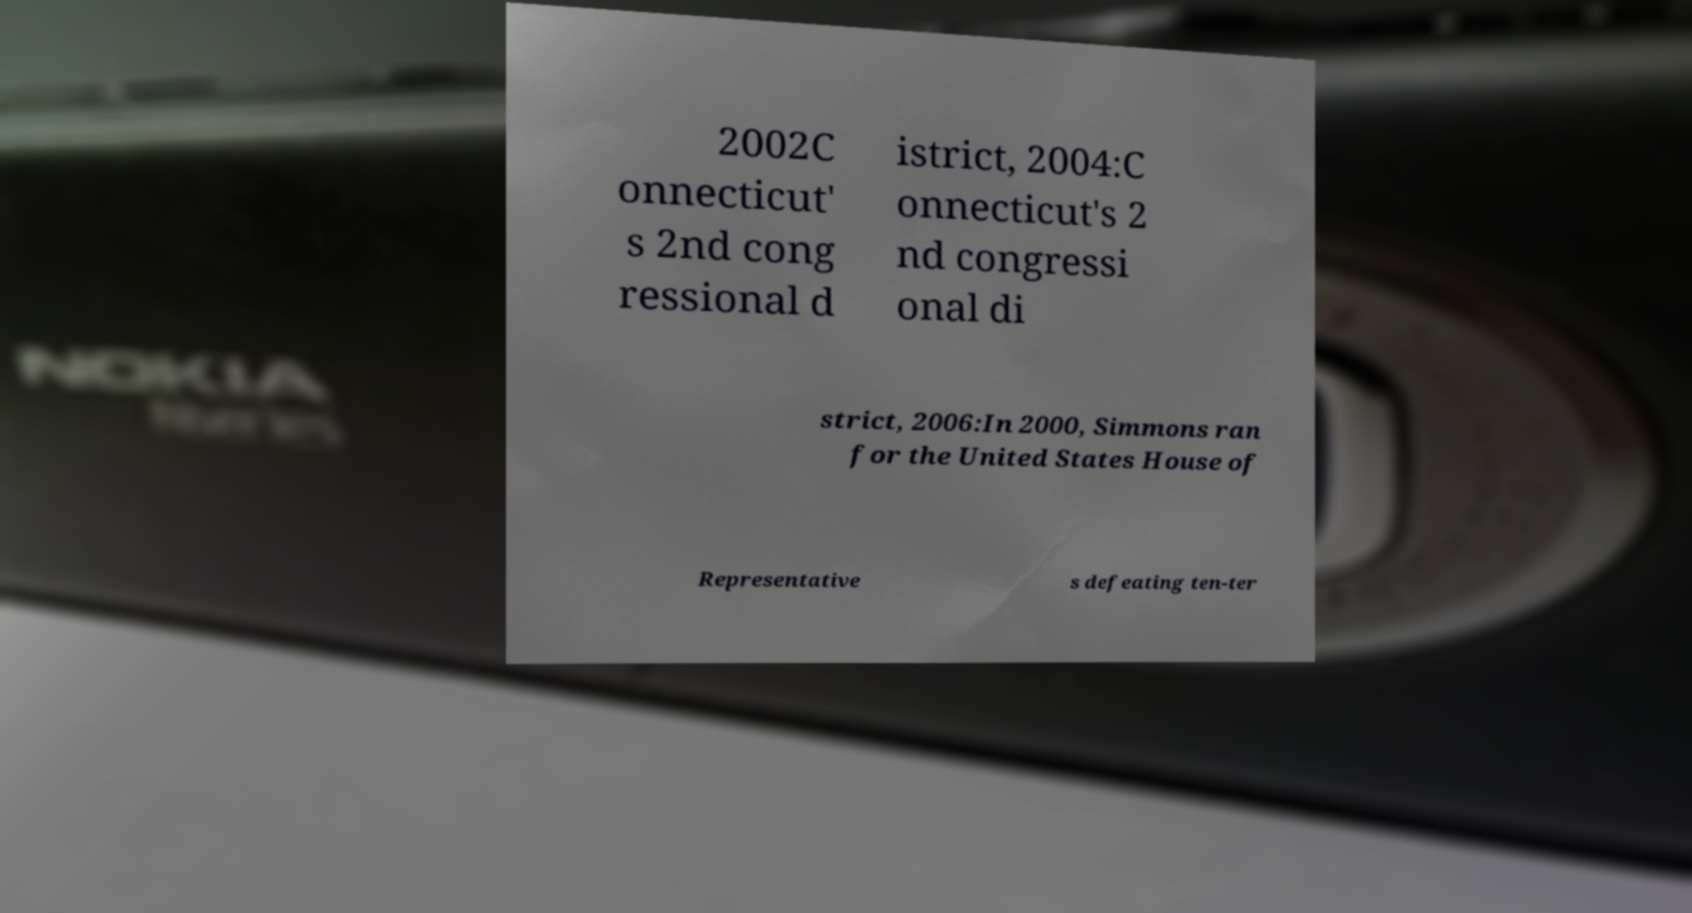What messages or text are displayed in this image? I need them in a readable, typed format. 2002C onnecticut' s 2nd cong ressional d istrict, 2004:C onnecticut's 2 nd congressi onal di strict, 2006:In 2000, Simmons ran for the United States House of Representative s defeating ten-ter 